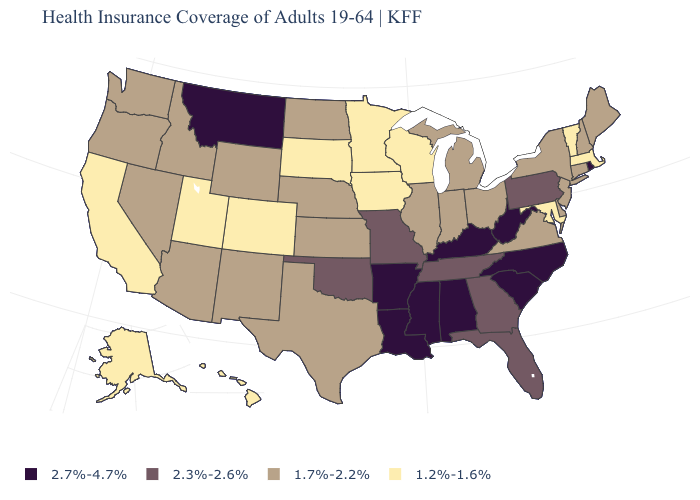What is the lowest value in the USA?
Give a very brief answer. 1.2%-1.6%. What is the value of Michigan?
Concise answer only. 1.7%-2.2%. What is the highest value in states that border Oklahoma?
Answer briefly. 2.7%-4.7%. What is the value of Connecticut?
Be succinct. 1.7%-2.2%. What is the value of Arizona?
Answer briefly. 1.7%-2.2%. What is the highest value in states that border Vermont?
Keep it brief. 1.7%-2.2%. Does the map have missing data?
Answer briefly. No. Name the states that have a value in the range 1.2%-1.6%?
Write a very short answer. Alaska, California, Colorado, Hawaii, Iowa, Maryland, Massachusetts, Minnesota, South Dakota, Utah, Vermont, Wisconsin. Does Virginia have the highest value in the South?
Short answer required. No. What is the value of Minnesota?
Quick response, please. 1.2%-1.6%. What is the value of Mississippi?
Be succinct. 2.7%-4.7%. Does the map have missing data?
Answer briefly. No. Does the first symbol in the legend represent the smallest category?
Be succinct. No. What is the lowest value in states that border Kentucky?
Give a very brief answer. 1.7%-2.2%. 